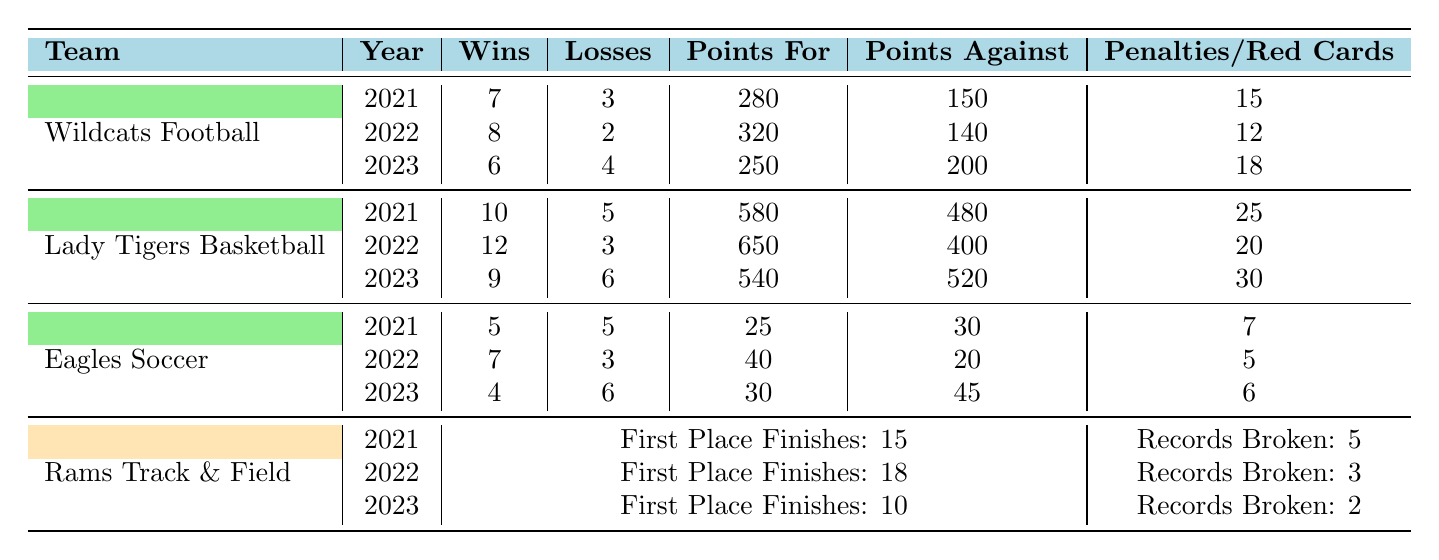What was the winning percentage of Wildcats Football in 2022? The winning percentage is calculated as the number of wins divided by the total number of games (wins + losses). In 2022, Wildcats Football had 8 wins and 2 losses. So, the percentage is 8 / (8 + 2) = 8 / 10 = 0.8, or 80%.
Answer: 80% How many more points did Lady Tigers Basketball score in 2022 compared to 2023? In 2022, they scored 650 points and in 2023, they scored 540 points. The difference is calculated as 650 - 540 = 110 points.
Answer: 110 points Which athletic team had the highest points scored in 2021? In 2021, the scores were 280 for Wildcats Football, 580 for Lady Tigers Basketball, 25 for Eagles Soccer, and 15 for Rams Track & Field. The highest is 580 points scored by Lady Tigers Basketball.
Answer: Lady Tigers Basketball Did Eagles Soccer improve its win-loss record from 2021 to 2022? In 2021, Eagles Soccer had 5 wins and 5 losses, making a record of 5-5. In 2022, they had 7 wins and 3 losses (7-3). Since 7 wins is better than 5 and 3 losses is better than 5, they improved their record.
Answer: Yes What was the average number of penalties for Wildcats Football over the three years? The penalties for Wildcats Football were 15 in 2021, 12 in 2022, and 18 in 2023. The average is calculated as (15 + 12 + 18) / 3 = 45 / 3 = 15.
Answer: 15 In which year did Rams Track & Field have the highest number of first-place finishes? Rams Track & Field had 15 first-place finishes in 2021, 18 in 2022, and 10 in 2023. The highest number of finishes is 18 in 2022.
Answer: 2022 How many total wins did Lady Tigers Basketball achieve over the past three years? Lady Tigers Basketball won 10 games in 2021, 12 in 2022, and 9 in 2023. The total wins are calculated as 10 + 12 + 9 = 31.
Answer: 31 Which team had the lowest points against in 2022? In 2022, the points against were 140 for Wildcats Football, 400 for Lady Tigers Basketball, 20 for Eagles Soccer, and not applicable for Rams Track & Field. Therefore, Eagles Soccer had the lowest points against with 20.
Answer: Eagles Soccer What is the trend in the number of penalties for Wildcats Football from 2021 to 2023? The penalties were 15 in 2021, 12 in 2022, and increased to 18 in 2023. This shows a decrease from 2021 to 2022, followed by an increase in 2023.
Answer: Decreased then increased What is the total number of red cards for Eagles Soccer over the three years? The red cards received were 7 in 2021, 5 in 2022, and 6 in 2023. The total is calculated as 7 + 5 + 6 = 18.
Answer: 18 